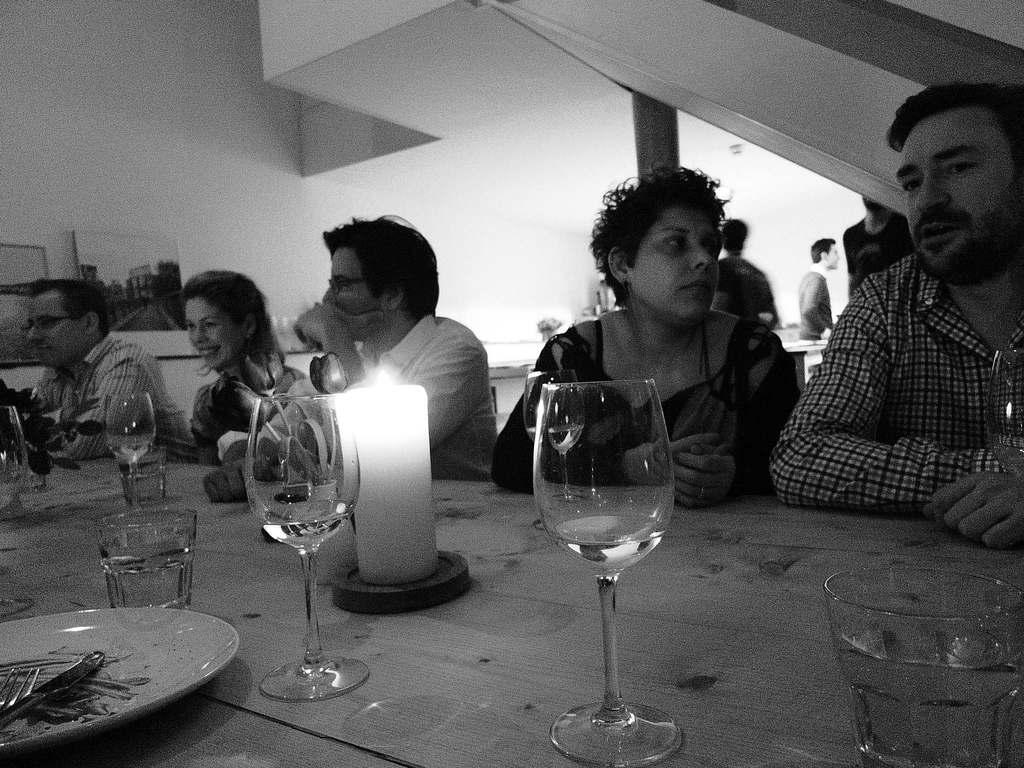How would you summarize this image in a sentence or two? In this image I can see few people sitting in front of the table. On the table there is a glass,candle,plate,fork. At the back side I can see a wall. 